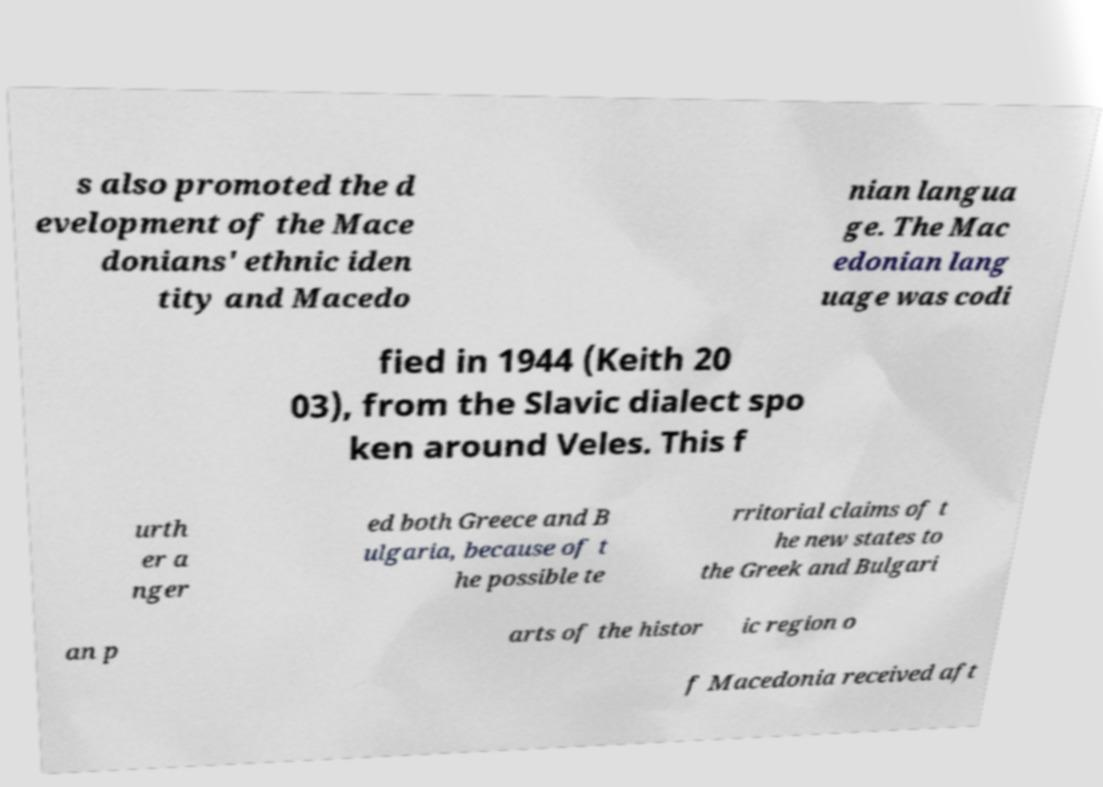What messages or text are displayed in this image? I need them in a readable, typed format. s also promoted the d evelopment of the Mace donians' ethnic iden tity and Macedo nian langua ge. The Mac edonian lang uage was codi fied in 1944 (Keith 20 03), from the Slavic dialect spo ken around Veles. This f urth er a nger ed both Greece and B ulgaria, because of t he possible te rritorial claims of t he new states to the Greek and Bulgari an p arts of the histor ic region o f Macedonia received aft 